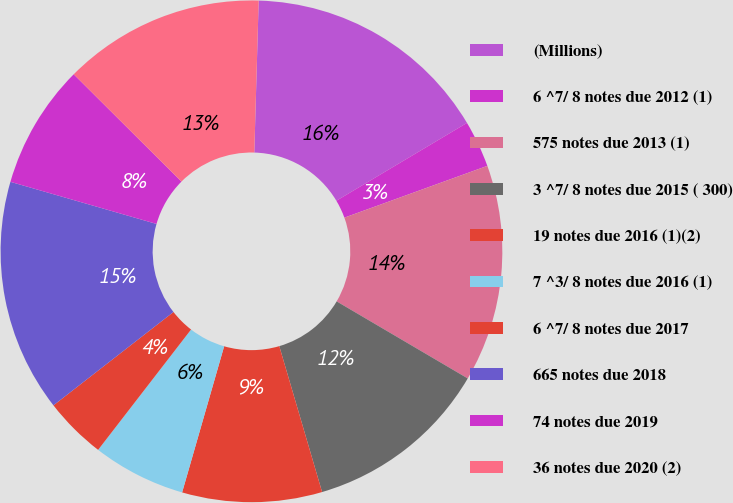<chart> <loc_0><loc_0><loc_500><loc_500><pie_chart><fcel>(Millions)<fcel>6 ^7/ 8 notes due 2012 (1)<fcel>575 notes due 2013 (1)<fcel>3 ^7/ 8 notes due 2015 ( 300)<fcel>19 notes due 2016 (1)(2)<fcel>7 ^3/ 8 notes due 2016 (1)<fcel>6 ^7/ 8 notes due 2017<fcel>665 notes due 2018<fcel>74 notes due 2019<fcel>36 notes due 2020 (2)<nl><fcel>15.99%<fcel>3.02%<fcel>13.99%<fcel>12.0%<fcel>9.0%<fcel>6.01%<fcel>4.01%<fcel>14.99%<fcel>8.0%<fcel>12.99%<nl></chart> 